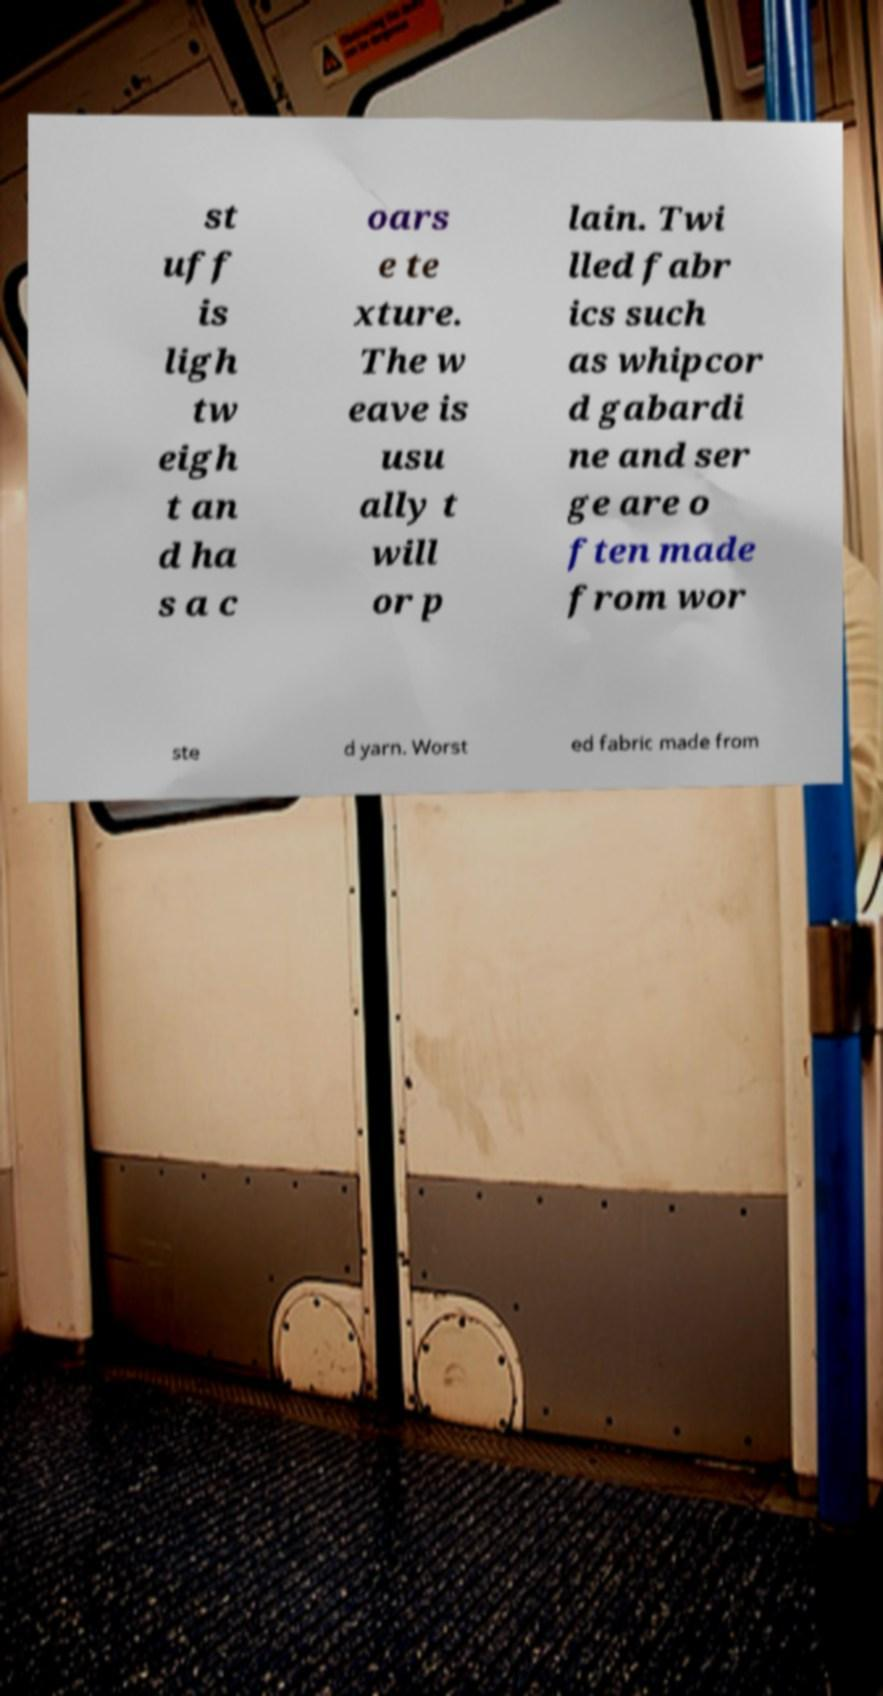I need the written content from this picture converted into text. Can you do that? st uff is ligh tw eigh t an d ha s a c oars e te xture. The w eave is usu ally t will or p lain. Twi lled fabr ics such as whipcor d gabardi ne and ser ge are o ften made from wor ste d yarn. Worst ed fabric made from 